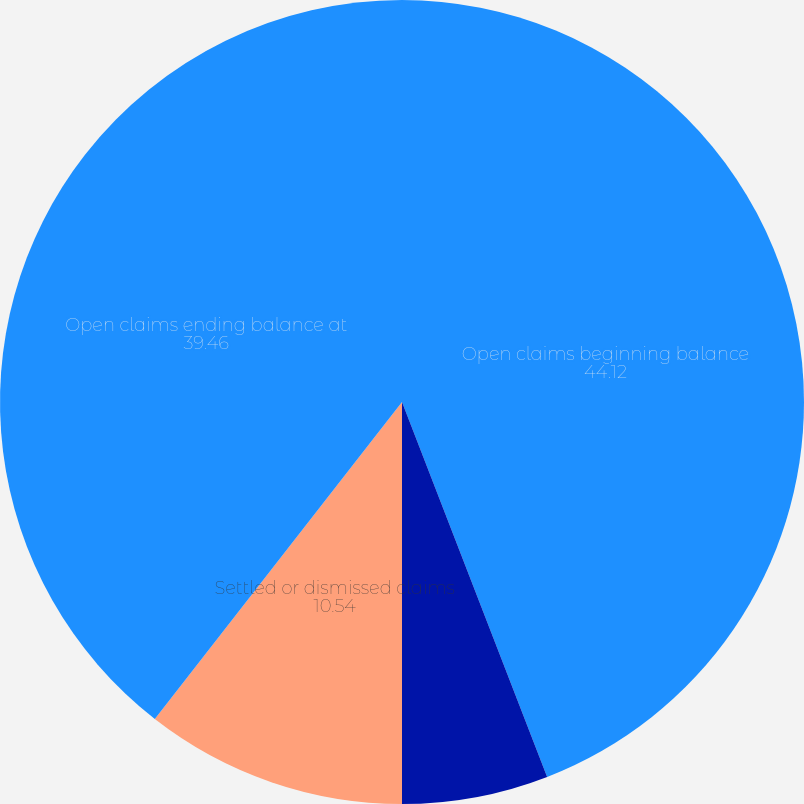Convert chart. <chart><loc_0><loc_0><loc_500><loc_500><pie_chart><fcel>Open claims beginning balance<fcel>New claims<fcel>Settled or dismissed claims<fcel>Open claims ending balance at<nl><fcel>44.12%<fcel>5.88%<fcel>10.54%<fcel>39.46%<nl></chart> 